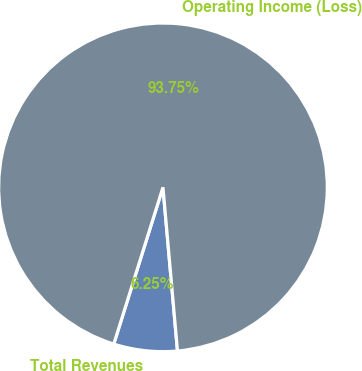<chart> <loc_0><loc_0><loc_500><loc_500><pie_chart><fcel>Total Revenues<fcel>Operating Income (Loss)<nl><fcel>6.25%<fcel>93.75%<nl></chart> 